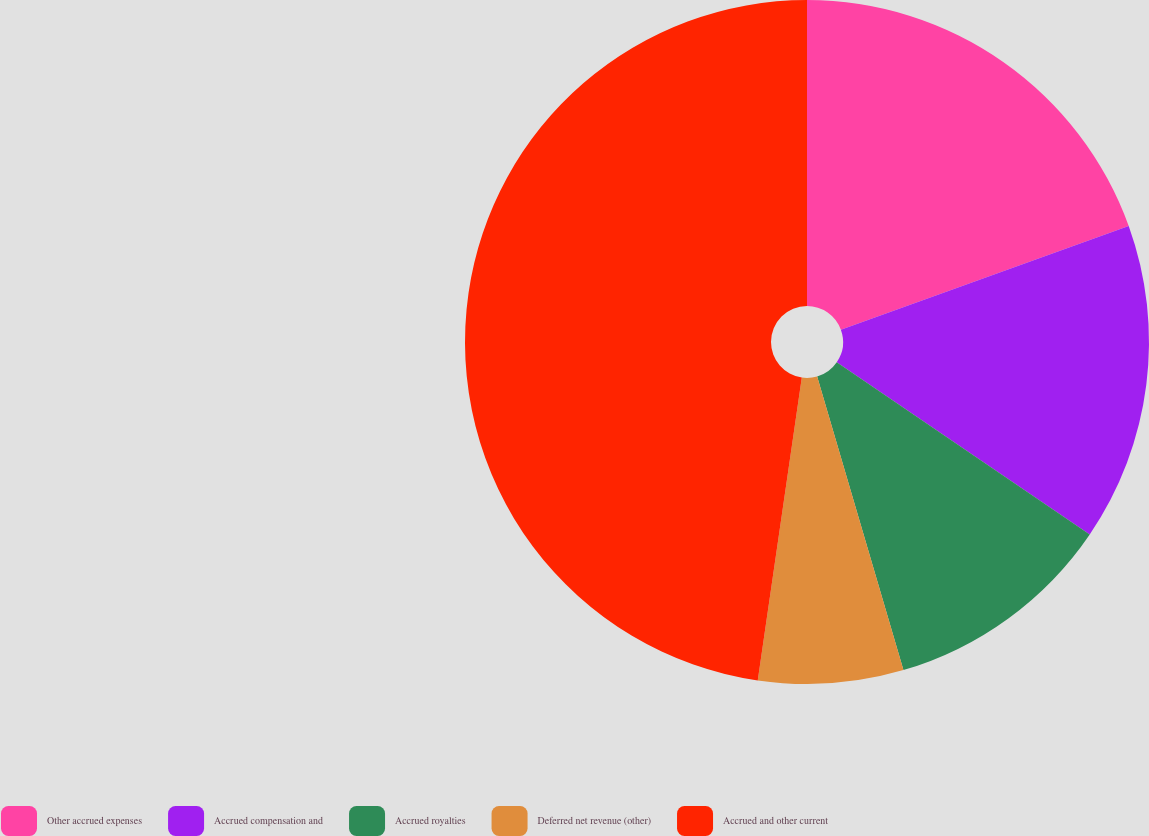<chart> <loc_0><loc_0><loc_500><loc_500><pie_chart><fcel>Other accrued expenses<fcel>Accrued compensation and<fcel>Accrued royalties<fcel>Deferred net revenue (other)<fcel>Accrued and other current<nl><fcel>19.49%<fcel>15.02%<fcel>10.94%<fcel>6.85%<fcel>47.7%<nl></chart> 